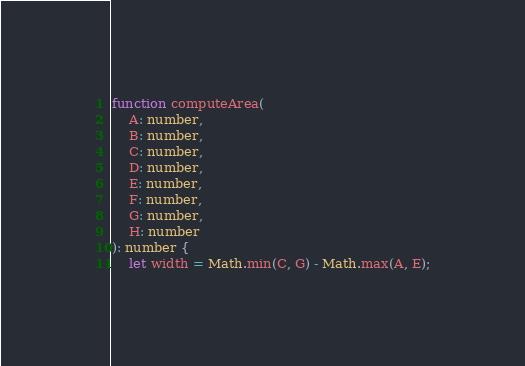<code> <loc_0><loc_0><loc_500><loc_500><_TypeScript_>function computeArea(
    A: number,
    B: number,
    C: number,
    D: number,
    E: number,
    F: number,
    G: number,
    H: number
): number {
    let width = Math.min(C, G) - Math.max(A, E);</code> 